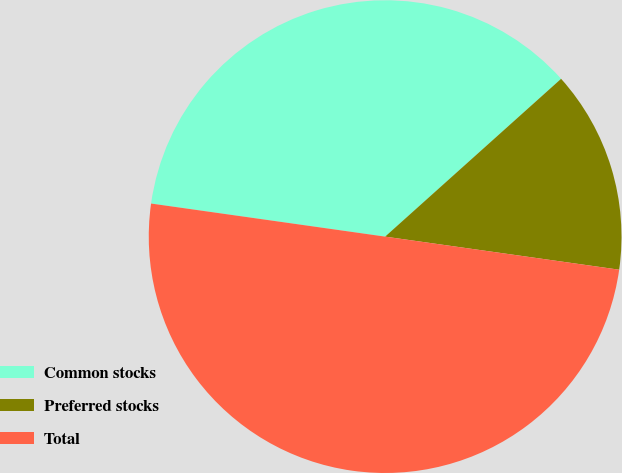Convert chart. <chart><loc_0><loc_0><loc_500><loc_500><pie_chart><fcel>Common stocks<fcel>Preferred stocks<fcel>Total<nl><fcel>36.13%<fcel>13.87%<fcel>50.0%<nl></chart> 